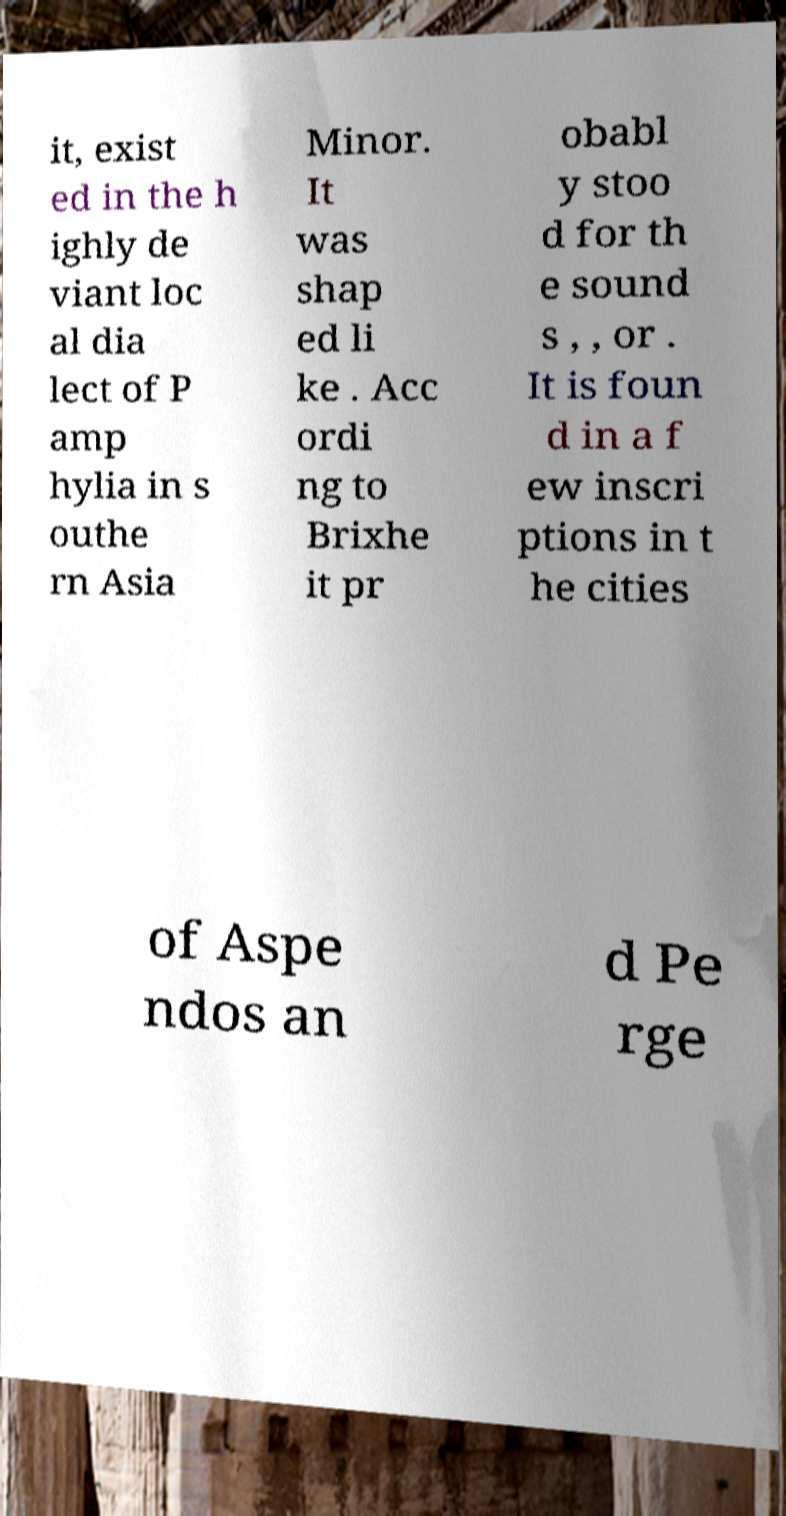Could you assist in decoding the text presented in this image and type it out clearly? it, exist ed in the h ighly de viant loc al dia lect of P amp hylia in s outhe rn Asia Minor. It was shap ed li ke . Acc ordi ng to Brixhe it pr obabl y stoo d for th e sound s , , or . It is foun d in a f ew inscri ptions in t he cities of Aspe ndos an d Pe rge 